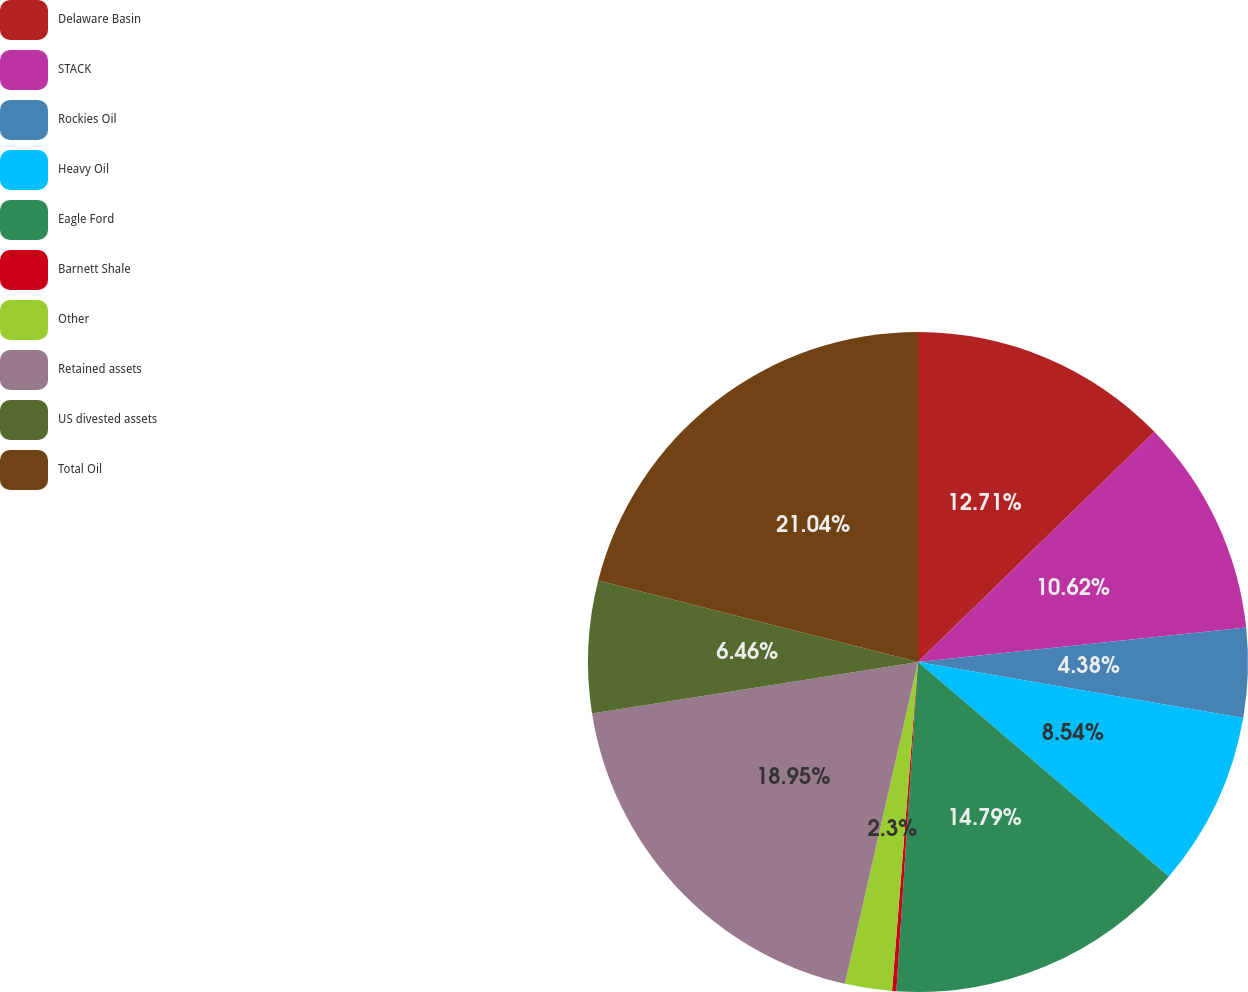Convert chart. <chart><loc_0><loc_0><loc_500><loc_500><pie_chart><fcel>Delaware Basin<fcel>STACK<fcel>Rockies Oil<fcel>Heavy Oil<fcel>Eagle Ford<fcel>Barnett Shale<fcel>Other<fcel>Retained assets<fcel>US divested assets<fcel>Total Oil<nl><fcel>12.71%<fcel>10.62%<fcel>4.38%<fcel>8.54%<fcel>14.79%<fcel>0.21%<fcel>2.3%<fcel>18.95%<fcel>6.46%<fcel>21.03%<nl></chart> 